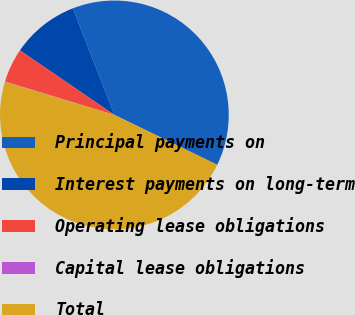Convert chart to OTSL. <chart><loc_0><loc_0><loc_500><loc_500><pie_chart><fcel>Principal payments on<fcel>Interest payments on long-term<fcel>Operating lease obligations<fcel>Capital lease obligations<fcel>Total<nl><fcel>38.09%<fcel>9.55%<fcel>4.81%<fcel>0.07%<fcel>47.47%<nl></chart> 